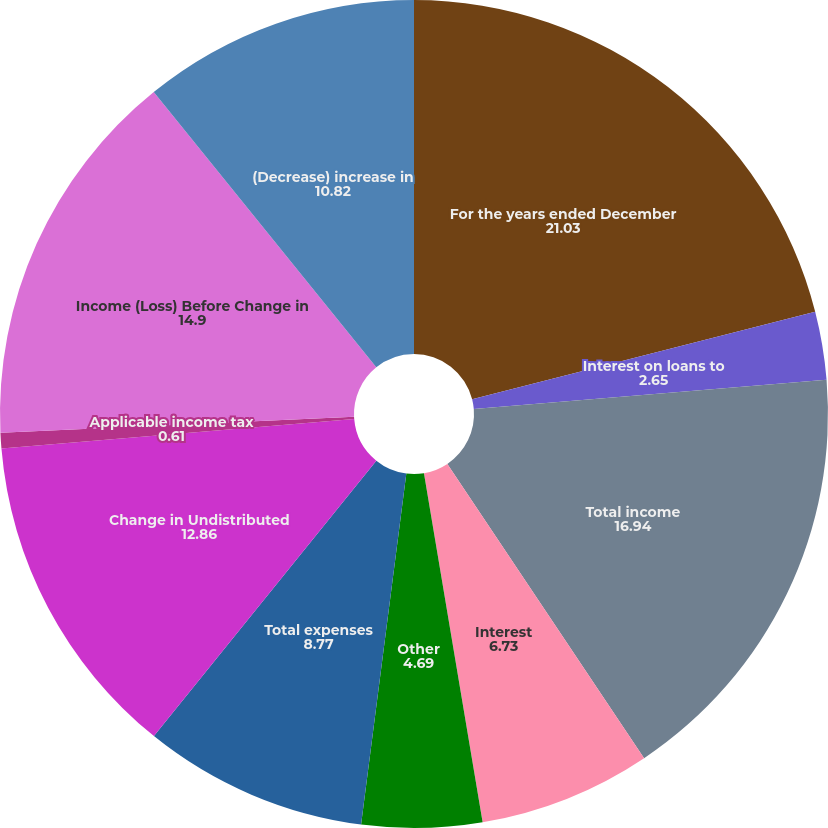<chart> <loc_0><loc_0><loc_500><loc_500><pie_chart><fcel>For the years ended December<fcel>Interest on loans to<fcel>Total income<fcel>Interest<fcel>Other<fcel>Total expenses<fcel>Change in Undistributed<fcel>Applicable income tax<fcel>Income (Loss) Before Change in<fcel>(Decrease) increase in<nl><fcel>21.03%<fcel>2.65%<fcel>16.94%<fcel>6.73%<fcel>4.69%<fcel>8.77%<fcel>12.86%<fcel>0.61%<fcel>14.9%<fcel>10.82%<nl></chart> 